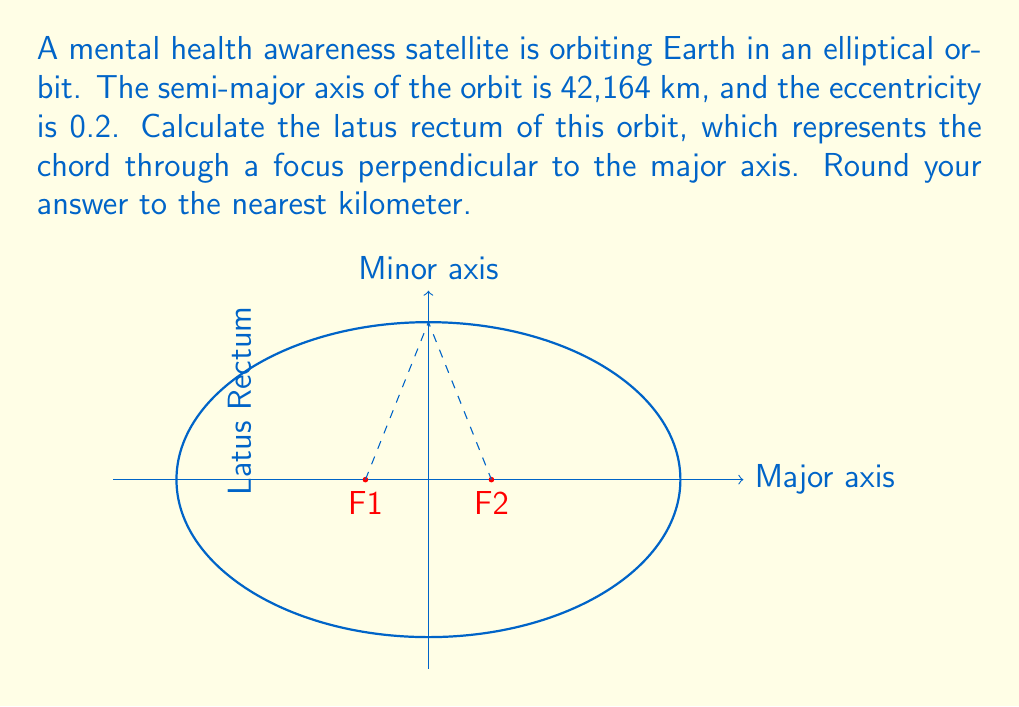Can you solve this math problem? Let's approach this step-by-step:

1) The latus rectum (L) of an ellipse is related to the semi-major axis (a) and the eccentricity (e) by the formula:

   $$L = \frac{2b^2}{a}$$

   where b is the semi-minor axis.

2) We're given:
   - Semi-major axis, a = 42,164 km
   - Eccentricity, e = 0.2

3) To find b, we can use the relationship:

   $$b^2 = a^2(1-e^2)$$

4) Let's calculate b^2:
   $$b^2 = 42,164^2 * (1-0.2^2)$$
   $$b^2 = 1,777,804,496 * 0.96$$
   $$b^2 = 1,706,692,316.16$$

5) Now we can substitute this into our latus rectum formula:

   $$L = \frac{2 * 1,706,692,316.16}{42,164}$$

6) Simplifying:
   $$L = 80,962.97 \text{ km}$$

7) Rounding to the nearest kilometer:
   $$L \approx 80,963 \text{ km}$$
Answer: 80,963 km 